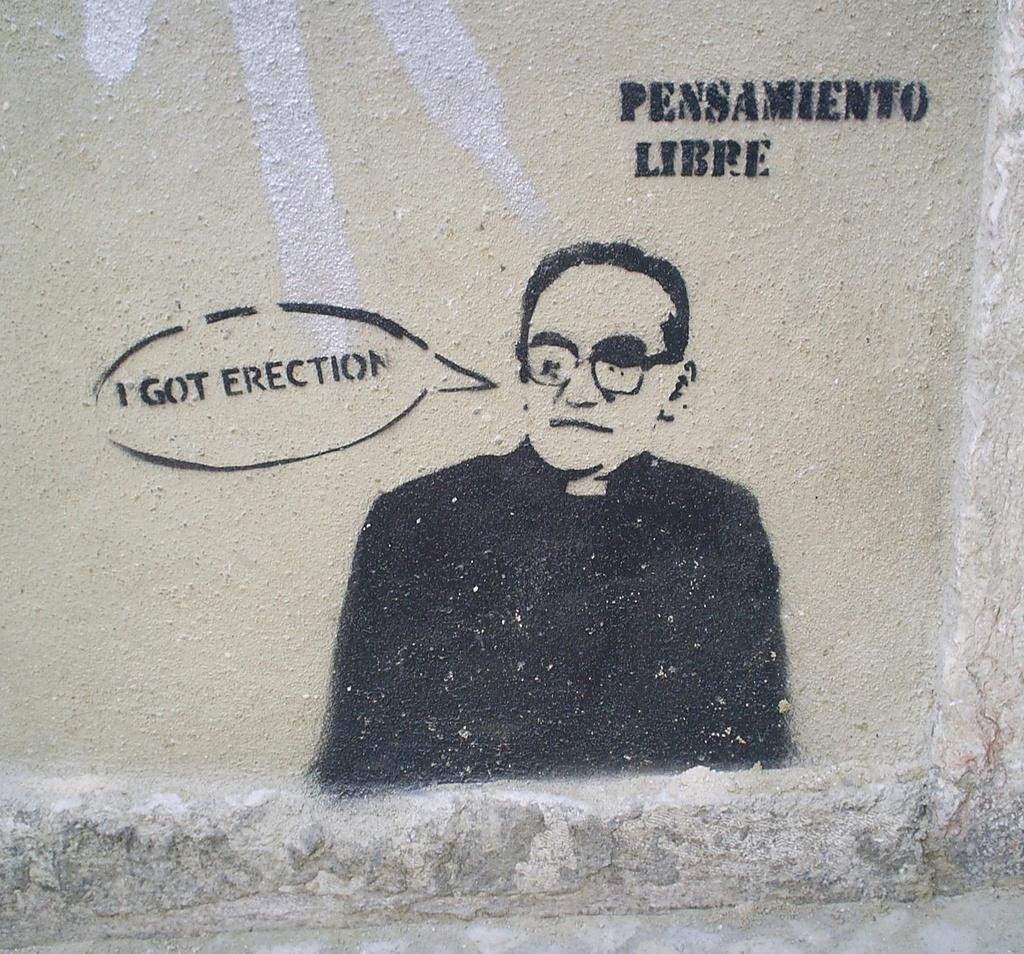What is depicted on the wall in the image? There is an image of a man on the wall. What else can be seen on the wall besides the image? There is writing on the wall. What is the man in the image wearing on his upper body? The man in the image is wearing a black coat and a shirt. What accessory is the man in the image wearing? The man in the image is wearing glasses. What type of knowledge can be gained from the spring in the image? There is no spring present in the image, so no knowledge can be gained from it. 